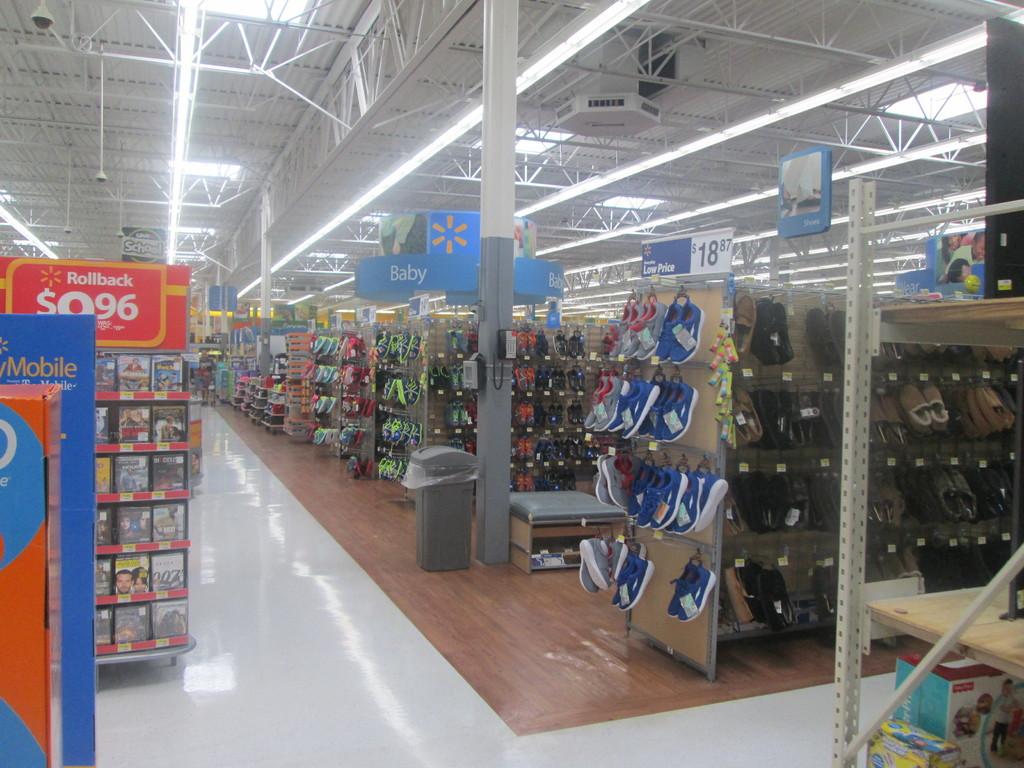What section of the store is shown?
Offer a very short reply. Baby. What section of walmart is this?
Offer a terse response. Baby. 